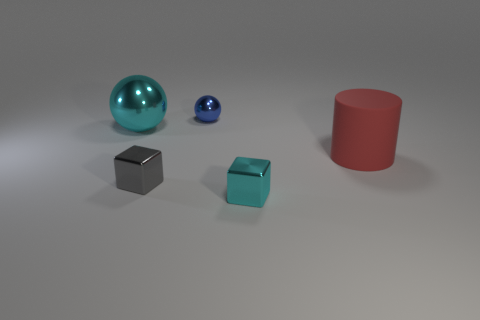What is the shape of the large thing that is on the right side of the metal thing that is on the right side of the blue metal ball?
Provide a succinct answer. Cylinder. What material is the thing that is the same color as the large metallic ball?
Keep it short and to the point. Metal. What is the color of the big ball that is made of the same material as the blue object?
Make the answer very short. Cyan. Are there any other things that have the same size as the red thing?
Your answer should be compact. Yes. There is a ball that is behind the large metallic object; is its color the same as the large thing behind the red thing?
Your answer should be compact. No. Is the number of big rubber cylinders in front of the large matte cylinder greater than the number of small blue metal objects that are on the left side of the gray cube?
Provide a short and direct response. No. The big metallic object that is the same shape as the small blue object is what color?
Provide a succinct answer. Cyan. Is there any other thing that has the same shape as the red matte thing?
Your answer should be very brief. No. Do the tiny cyan object and the small metallic thing to the left of the tiny metallic sphere have the same shape?
Keep it short and to the point. Yes. What number of other things are made of the same material as the big red object?
Keep it short and to the point. 0. 